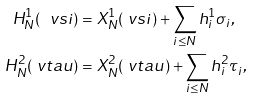Convert formula to latex. <formula><loc_0><loc_0><loc_500><loc_500>H _ { N } ^ { 1 } ( \ v s i ) & = X _ { N } ^ { 1 } ( \ v s i ) + \sum _ { i \leq N } h _ { i } ^ { 1 } \sigma _ { i } , \\ H _ { N } ^ { 2 } ( \ v t a u ) & = X _ { N } ^ { 2 } ( \ v t a u ) + \sum _ { i \leq N } h _ { i } ^ { 2 } \tau _ { i } ,</formula> 